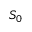Convert formula to latex. <formula><loc_0><loc_0><loc_500><loc_500>S _ { 0 }</formula> 